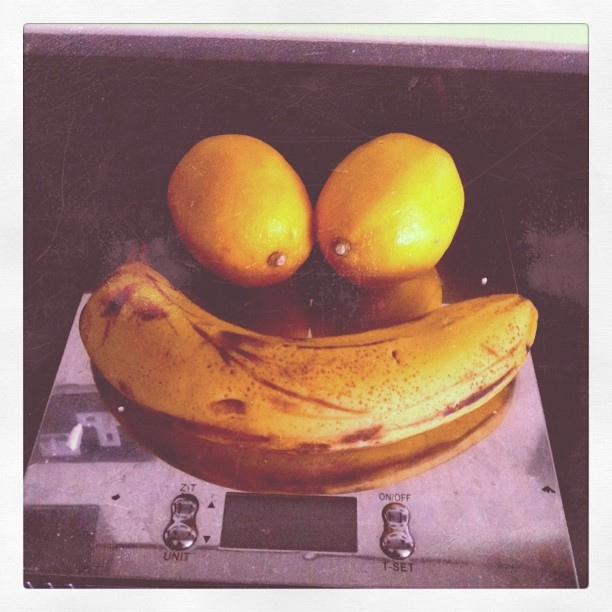Please identify all text content in this image. ON OFF T-SET Z IT UNIT 